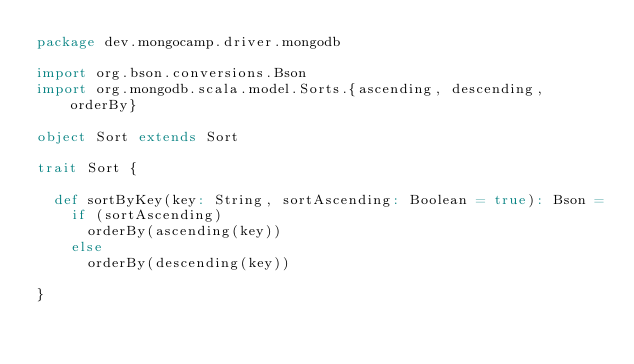Convert code to text. <code><loc_0><loc_0><loc_500><loc_500><_Scala_>package dev.mongocamp.driver.mongodb

import org.bson.conversions.Bson
import org.mongodb.scala.model.Sorts.{ascending, descending, orderBy}

object Sort extends Sort

trait Sort {

  def sortByKey(key: String, sortAscending: Boolean = true): Bson =
    if (sortAscending)
      orderBy(ascending(key))
    else
      orderBy(descending(key))

}
</code> 